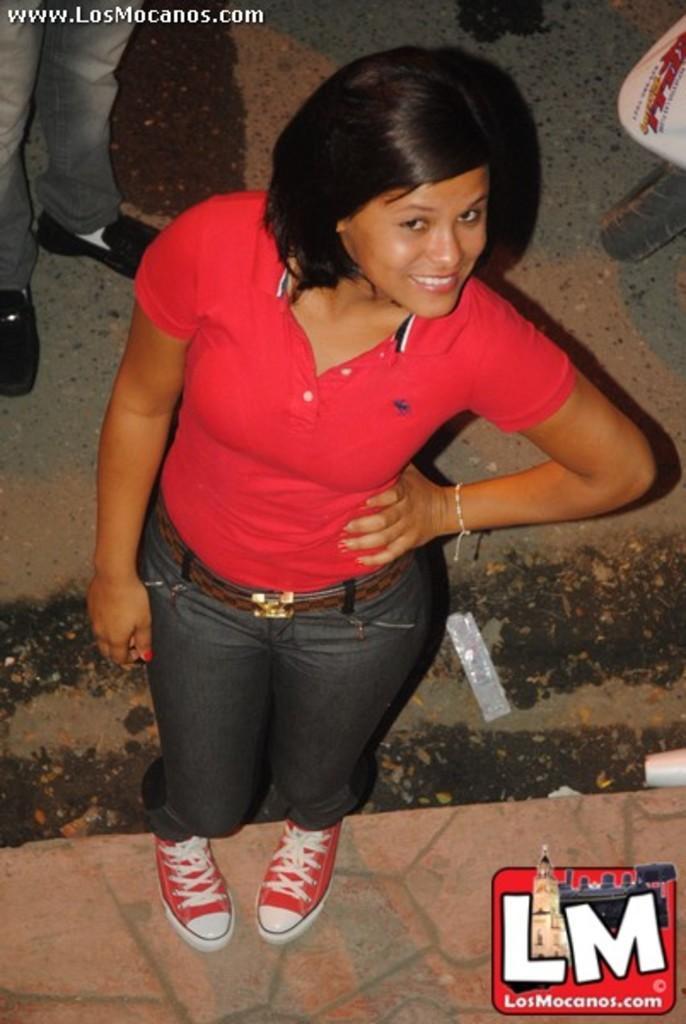Can you describe this image briefly? In this image there is a lady standing on the pavement. In the background of the image there is road. At the top of the image there is text. At the bottom of the image there is logo. 